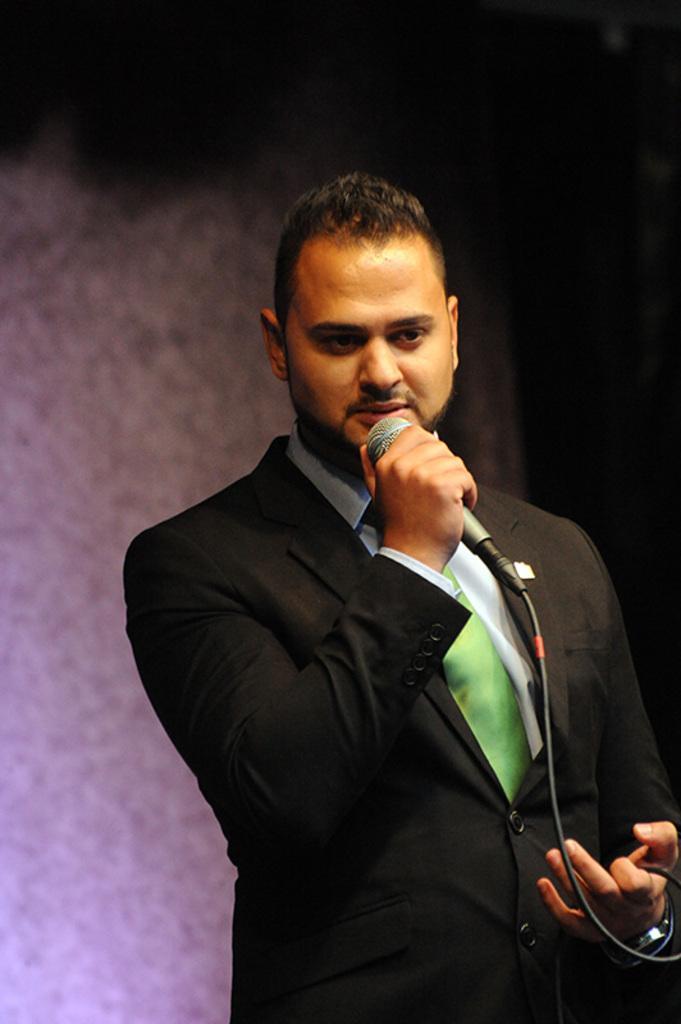In one or two sentences, can you explain what this image depicts? In this image i can see a man standing holding a microphone, at the back ground there is a wall. 